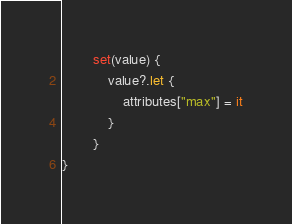<code> <loc_0><loc_0><loc_500><loc_500><_Kotlin_>		set(value) {
			value?.let {
				attributes["max"] = it
			}
		}
}	
</code> 